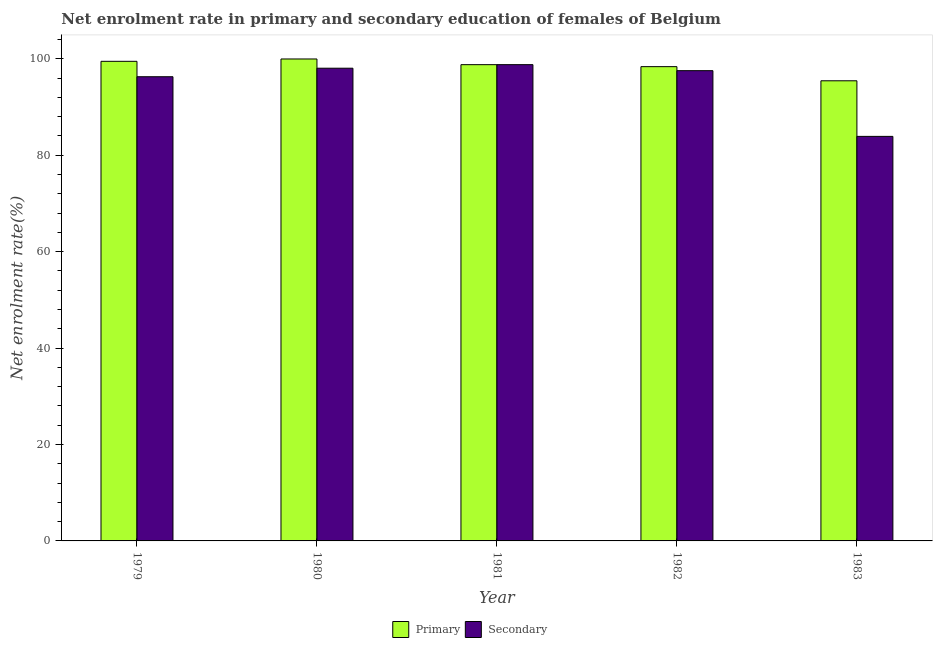How many groups of bars are there?
Offer a terse response. 5. Are the number of bars per tick equal to the number of legend labels?
Your answer should be very brief. Yes. What is the label of the 4th group of bars from the left?
Ensure brevity in your answer.  1982. What is the enrollment rate in secondary education in 1980?
Give a very brief answer. 98.04. Across all years, what is the maximum enrollment rate in primary education?
Offer a very short reply. 99.96. Across all years, what is the minimum enrollment rate in secondary education?
Give a very brief answer. 83.9. What is the total enrollment rate in secondary education in the graph?
Provide a succinct answer. 474.52. What is the difference between the enrollment rate in primary education in 1980 and that in 1982?
Offer a terse response. 1.59. What is the difference between the enrollment rate in primary education in 1980 and the enrollment rate in secondary education in 1982?
Provide a succinct answer. 1.59. What is the average enrollment rate in primary education per year?
Make the answer very short. 98.4. What is the ratio of the enrollment rate in secondary education in 1979 to that in 1982?
Provide a succinct answer. 0.99. What is the difference between the highest and the second highest enrollment rate in secondary education?
Your answer should be very brief. 0.74. What is the difference between the highest and the lowest enrollment rate in primary education?
Offer a terse response. 4.52. In how many years, is the enrollment rate in secondary education greater than the average enrollment rate in secondary education taken over all years?
Offer a very short reply. 4. Is the sum of the enrollment rate in primary education in 1980 and 1981 greater than the maximum enrollment rate in secondary education across all years?
Keep it short and to the point. Yes. What does the 1st bar from the left in 1982 represents?
Provide a short and direct response. Primary. What does the 1st bar from the right in 1982 represents?
Ensure brevity in your answer.  Secondary. How many bars are there?
Ensure brevity in your answer.  10. Are all the bars in the graph horizontal?
Provide a short and direct response. No. How many years are there in the graph?
Keep it short and to the point. 5. Are the values on the major ticks of Y-axis written in scientific E-notation?
Provide a succinct answer. No. Does the graph contain any zero values?
Offer a very short reply. No. Does the graph contain grids?
Provide a succinct answer. No. Where does the legend appear in the graph?
Offer a very short reply. Bottom center. How many legend labels are there?
Give a very brief answer. 2. What is the title of the graph?
Give a very brief answer. Net enrolment rate in primary and secondary education of females of Belgium. What is the label or title of the Y-axis?
Provide a short and direct response. Net enrolment rate(%). What is the Net enrolment rate(%) in Primary in 1979?
Provide a succinct answer. 99.47. What is the Net enrolment rate(%) in Secondary in 1979?
Offer a terse response. 96.27. What is the Net enrolment rate(%) in Primary in 1980?
Offer a very short reply. 99.96. What is the Net enrolment rate(%) of Secondary in 1980?
Your response must be concise. 98.04. What is the Net enrolment rate(%) in Primary in 1981?
Keep it short and to the point. 98.78. What is the Net enrolment rate(%) in Secondary in 1981?
Offer a very short reply. 98.78. What is the Net enrolment rate(%) in Primary in 1982?
Give a very brief answer. 98.37. What is the Net enrolment rate(%) of Secondary in 1982?
Make the answer very short. 97.53. What is the Net enrolment rate(%) of Primary in 1983?
Offer a very short reply. 95.43. What is the Net enrolment rate(%) of Secondary in 1983?
Your answer should be very brief. 83.9. Across all years, what is the maximum Net enrolment rate(%) of Primary?
Provide a short and direct response. 99.96. Across all years, what is the maximum Net enrolment rate(%) of Secondary?
Provide a short and direct response. 98.78. Across all years, what is the minimum Net enrolment rate(%) of Primary?
Ensure brevity in your answer.  95.43. Across all years, what is the minimum Net enrolment rate(%) of Secondary?
Your response must be concise. 83.9. What is the total Net enrolment rate(%) of Primary in the graph?
Give a very brief answer. 492. What is the total Net enrolment rate(%) in Secondary in the graph?
Give a very brief answer. 474.52. What is the difference between the Net enrolment rate(%) in Primary in 1979 and that in 1980?
Offer a terse response. -0.49. What is the difference between the Net enrolment rate(%) in Secondary in 1979 and that in 1980?
Offer a very short reply. -1.77. What is the difference between the Net enrolment rate(%) in Primary in 1979 and that in 1981?
Provide a short and direct response. 0.69. What is the difference between the Net enrolment rate(%) of Secondary in 1979 and that in 1981?
Keep it short and to the point. -2.51. What is the difference between the Net enrolment rate(%) in Primary in 1979 and that in 1982?
Make the answer very short. 1.1. What is the difference between the Net enrolment rate(%) in Secondary in 1979 and that in 1982?
Keep it short and to the point. -1.26. What is the difference between the Net enrolment rate(%) in Primary in 1979 and that in 1983?
Offer a very short reply. 4.04. What is the difference between the Net enrolment rate(%) of Secondary in 1979 and that in 1983?
Make the answer very short. 12.37. What is the difference between the Net enrolment rate(%) in Primary in 1980 and that in 1981?
Keep it short and to the point. 1.18. What is the difference between the Net enrolment rate(%) in Secondary in 1980 and that in 1981?
Ensure brevity in your answer.  -0.74. What is the difference between the Net enrolment rate(%) of Primary in 1980 and that in 1982?
Provide a succinct answer. 1.59. What is the difference between the Net enrolment rate(%) of Secondary in 1980 and that in 1982?
Offer a terse response. 0.51. What is the difference between the Net enrolment rate(%) in Primary in 1980 and that in 1983?
Keep it short and to the point. 4.52. What is the difference between the Net enrolment rate(%) in Secondary in 1980 and that in 1983?
Your response must be concise. 14.14. What is the difference between the Net enrolment rate(%) in Primary in 1981 and that in 1982?
Provide a short and direct response. 0.41. What is the difference between the Net enrolment rate(%) of Secondary in 1981 and that in 1982?
Make the answer very short. 1.25. What is the difference between the Net enrolment rate(%) in Primary in 1981 and that in 1983?
Your response must be concise. 3.34. What is the difference between the Net enrolment rate(%) in Secondary in 1981 and that in 1983?
Give a very brief answer. 14.88. What is the difference between the Net enrolment rate(%) of Primary in 1982 and that in 1983?
Provide a succinct answer. 2.93. What is the difference between the Net enrolment rate(%) of Secondary in 1982 and that in 1983?
Offer a terse response. 13.63. What is the difference between the Net enrolment rate(%) in Primary in 1979 and the Net enrolment rate(%) in Secondary in 1980?
Offer a terse response. 1.43. What is the difference between the Net enrolment rate(%) in Primary in 1979 and the Net enrolment rate(%) in Secondary in 1981?
Provide a short and direct response. 0.69. What is the difference between the Net enrolment rate(%) of Primary in 1979 and the Net enrolment rate(%) of Secondary in 1982?
Provide a succinct answer. 1.94. What is the difference between the Net enrolment rate(%) of Primary in 1979 and the Net enrolment rate(%) of Secondary in 1983?
Provide a succinct answer. 15.57. What is the difference between the Net enrolment rate(%) in Primary in 1980 and the Net enrolment rate(%) in Secondary in 1981?
Your answer should be very brief. 1.18. What is the difference between the Net enrolment rate(%) of Primary in 1980 and the Net enrolment rate(%) of Secondary in 1982?
Offer a very short reply. 2.43. What is the difference between the Net enrolment rate(%) in Primary in 1980 and the Net enrolment rate(%) in Secondary in 1983?
Your response must be concise. 16.06. What is the difference between the Net enrolment rate(%) of Primary in 1981 and the Net enrolment rate(%) of Secondary in 1982?
Offer a very short reply. 1.25. What is the difference between the Net enrolment rate(%) in Primary in 1981 and the Net enrolment rate(%) in Secondary in 1983?
Offer a terse response. 14.88. What is the difference between the Net enrolment rate(%) of Primary in 1982 and the Net enrolment rate(%) of Secondary in 1983?
Your answer should be very brief. 14.46. What is the average Net enrolment rate(%) in Primary per year?
Your answer should be very brief. 98.4. What is the average Net enrolment rate(%) of Secondary per year?
Make the answer very short. 94.91. In the year 1979, what is the difference between the Net enrolment rate(%) in Primary and Net enrolment rate(%) in Secondary?
Offer a very short reply. 3.2. In the year 1980, what is the difference between the Net enrolment rate(%) in Primary and Net enrolment rate(%) in Secondary?
Your answer should be compact. 1.92. In the year 1981, what is the difference between the Net enrolment rate(%) in Primary and Net enrolment rate(%) in Secondary?
Provide a succinct answer. -0. In the year 1982, what is the difference between the Net enrolment rate(%) of Primary and Net enrolment rate(%) of Secondary?
Offer a terse response. 0.83. In the year 1983, what is the difference between the Net enrolment rate(%) of Primary and Net enrolment rate(%) of Secondary?
Offer a terse response. 11.53. What is the ratio of the Net enrolment rate(%) of Primary in 1979 to that in 1981?
Provide a succinct answer. 1.01. What is the ratio of the Net enrolment rate(%) in Secondary in 1979 to that in 1981?
Offer a very short reply. 0.97. What is the ratio of the Net enrolment rate(%) of Primary in 1979 to that in 1982?
Offer a terse response. 1.01. What is the ratio of the Net enrolment rate(%) of Secondary in 1979 to that in 1982?
Your answer should be very brief. 0.99. What is the ratio of the Net enrolment rate(%) in Primary in 1979 to that in 1983?
Your answer should be very brief. 1.04. What is the ratio of the Net enrolment rate(%) in Secondary in 1979 to that in 1983?
Provide a short and direct response. 1.15. What is the ratio of the Net enrolment rate(%) in Primary in 1980 to that in 1981?
Keep it short and to the point. 1.01. What is the ratio of the Net enrolment rate(%) of Primary in 1980 to that in 1982?
Provide a succinct answer. 1.02. What is the ratio of the Net enrolment rate(%) of Primary in 1980 to that in 1983?
Provide a short and direct response. 1.05. What is the ratio of the Net enrolment rate(%) in Secondary in 1980 to that in 1983?
Offer a terse response. 1.17. What is the ratio of the Net enrolment rate(%) of Primary in 1981 to that in 1982?
Keep it short and to the point. 1. What is the ratio of the Net enrolment rate(%) of Secondary in 1981 to that in 1982?
Give a very brief answer. 1.01. What is the ratio of the Net enrolment rate(%) in Primary in 1981 to that in 1983?
Offer a terse response. 1.03. What is the ratio of the Net enrolment rate(%) of Secondary in 1981 to that in 1983?
Keep it short and to the point. 1.18. What is the ratio of the Net enrolment rate(%) of Primary in 1982 to that in 1983?
Give a very brief answer. 1.03. What is the ratio of the Net enrolment rate(%) of Secondary in 1982 to that in 1983?
Your answer should be very brief. 1.16. What is the difference between the highest and the second highest Net enrolment rate(%) in Primary?
Provide a succinct answer. 0.49. What is the difference between the highest and the second highest Net enrolment rate(%) in Secondary?
Provide a short and direct response. 0.74. What is the difference between the highest and the lowest Net enrolment rate(%) of Primary?
Your response must be concise. 4.52. What is the difference between the highest and the lowest Net enrolment rate(%) in Secondary?
Keep it short and to the point. 14.88. 